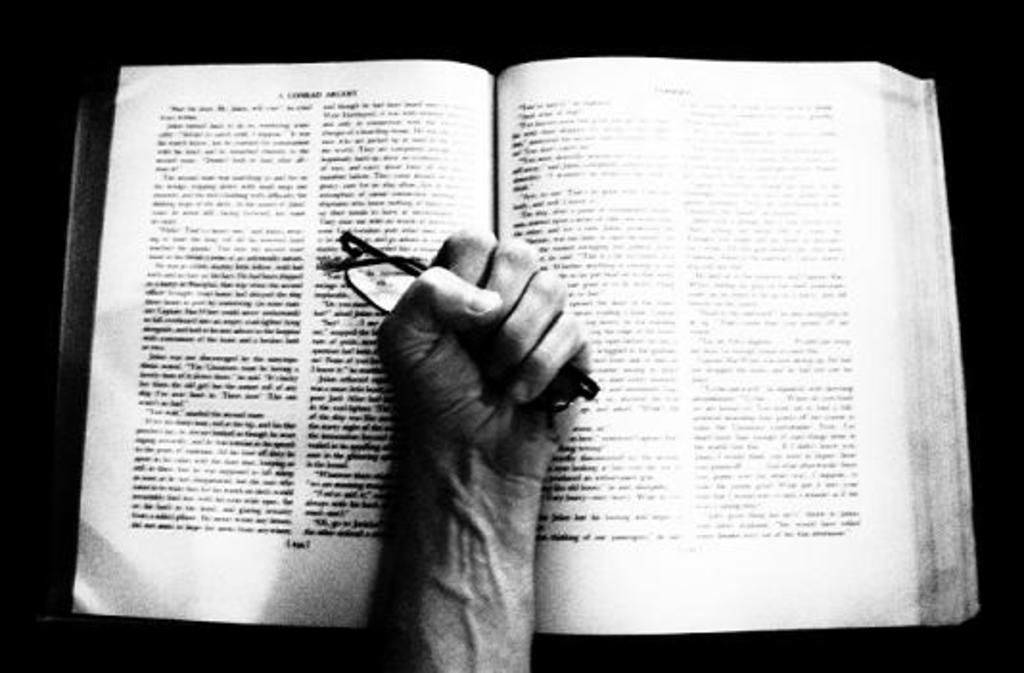What is the color scheme of the image? The image is black and white. What can be seen in the center of the image? There is a person's hand holding spectacles in the center of the image. What other object is present in the image? There is a book in the image. What type of bomb is being defused in the image? There is no bomb present in the image; it features a person's hand holding spectacles and a book. How many planes can be seen flying in the image? There are no planes visible in the image. 